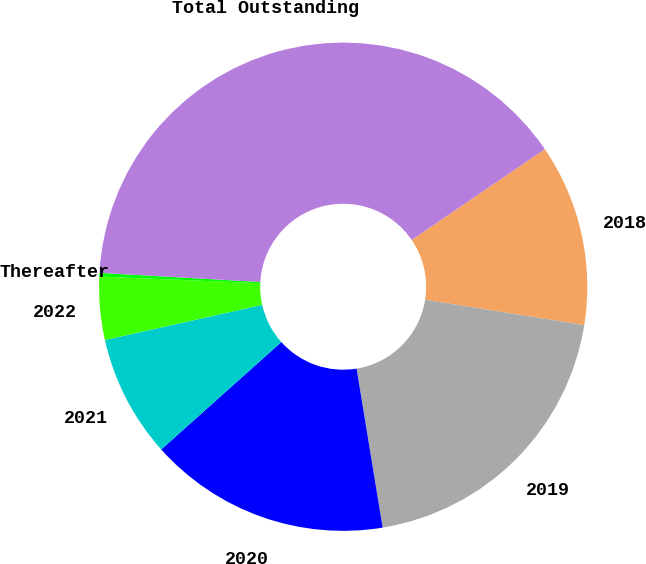Convert chart to OTSL. <chart><loc_0><loc_0><loc_500><loc_500><pie_chart><fcel>2018<fcel>2019<fcel>2020<fcel>2021<fcel>2022<fcel>Thereafter<fcel>Total Outstanding<nl><fcel>12.04%<fcel>19.9%<fcel>15.97%<fcel>8.11%<fcel>4.17%<fcel>0.24%<fcel>39.56%<nl></chart> 